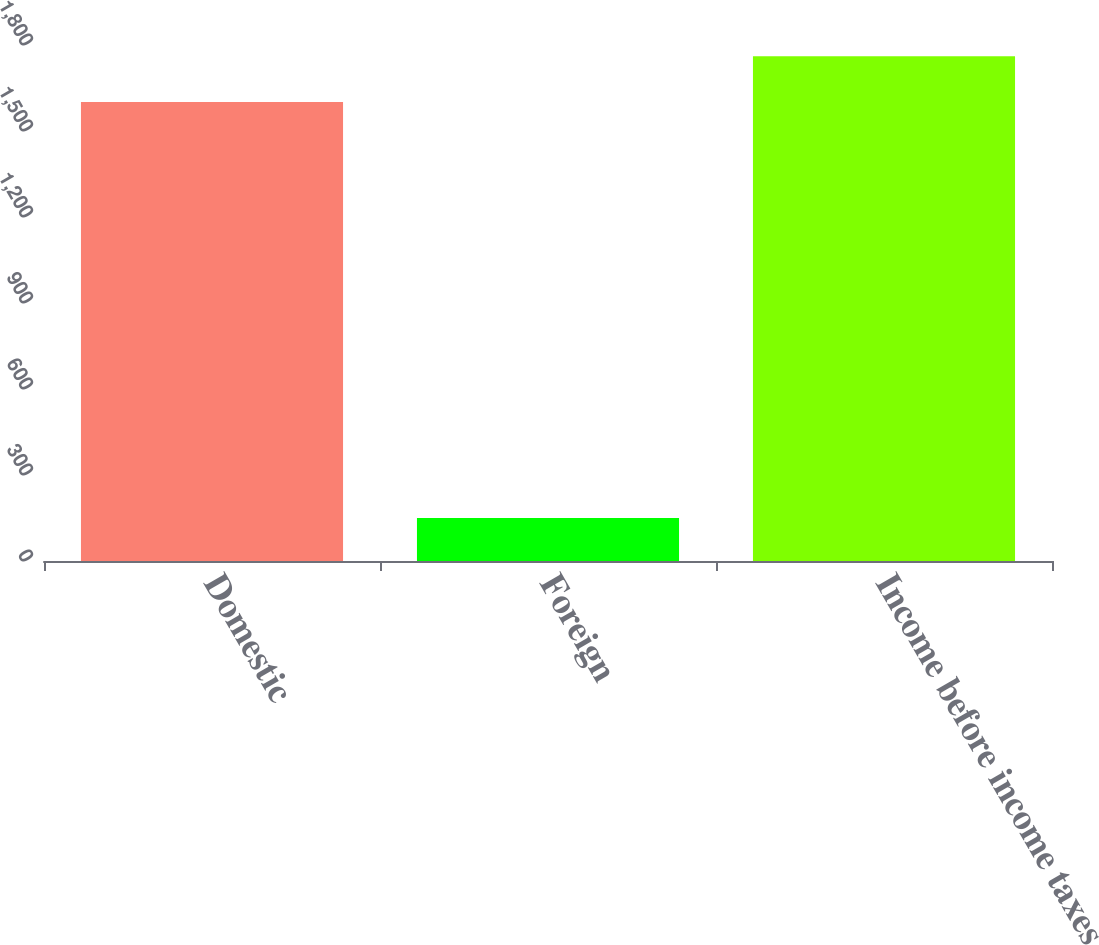Convert chart to OTSL. <chart><loc_0><loc_0><loc_500><loc_500><bar_chart><fcel>Domestic<fcel>Foreign<fcel>Income before income taxes<nl><fcel>1601<fcel>150<fcel>1761.1<nl></chart> 